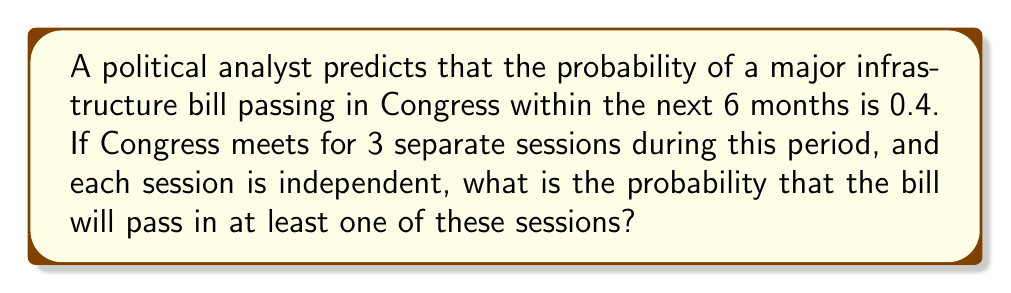Can you solve this math problem? Let's approach this step-by-step:

1) First, we need to understand what the question is asking. We're looking for the probability of the bill passing in at least one session out of three.

2) It's often easier to calculate the probability of an event not happening and then subtract that from 1. So, let's find the probability of the bill not passing in any of the three sessions.

3) The probability of the bill not passing in a single session is:
   $1 - 0.4 = 0.6$

4) Since the sessions are independent, we can use the multiplication rule of probability. The probability of the bill not passing in all three sessions is:
   $0.6 \times 0.6 \times 0.6 = 0.6^3 = 0.216$

5) Now, the probability of the bill passing in at least one session is the opposite of it not passing in any session:
   $1 - 0.216 = 0.784$

6) Therefore, the probability of the infrastructure bill passing in at least one of the three sessions is 0.784 or 78.4%.
Answer: $0.784$ or $78.4\%$ 